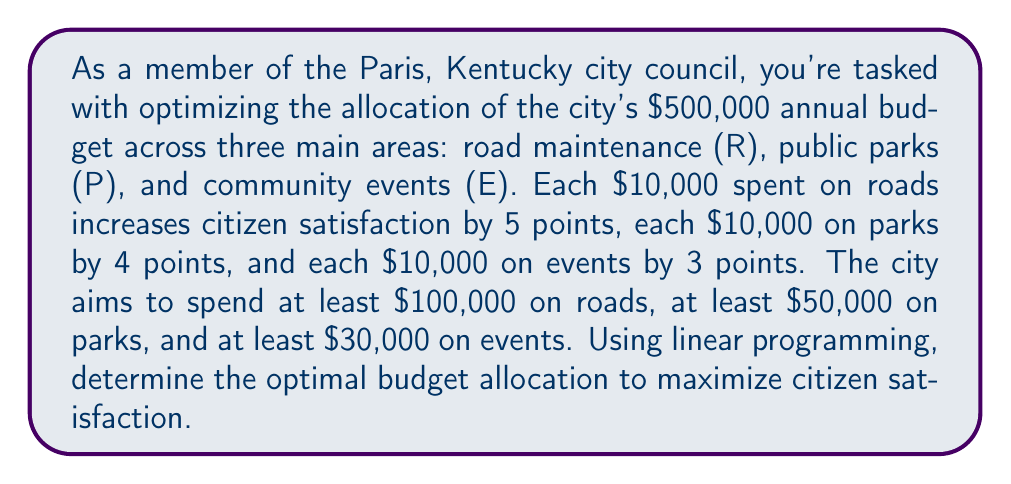Provide a solution to this math problem. Let's approach this step-by-step using linear programming:

1) Define variables:
   $R$ = amount spent on roads (in $10,000 units)
   $P$ = amount spent on parks (in $10,000 units)
   $E$ = amount spent on events (in $10,000 units)

2) Objective function:
   Maximize $Z = 5R + 4P + 3E$ (citizen satisfaction)

3) Constraints:
   $R + P + E \leq 50$ (total budget constraint)
   $R \geq 10$ (minimum road spending)
   $P \geq 5$ (minimum park spending)
   $E \geq 3$ (minimum event spending)
   $R, P, E \geq 0$ (non-negativity constraints)

4) Set up the linear programming tableau:
   $$
   \begin{array}{c|ccc|c}
     & R & P & E & RHS \\
   \hline
   Z & -5 & -4 & -3 & 0 \\
   S_1 & 1 & 1 & 1 & 50 \\
   S_2 & -1 & 0 & 0 & -10 \\
   S_3 & 0 & -1 & 0 & -5 \\
   S_4 & 0 & 0 & -1 & -3 \\
   \end{array}
   $$

5) Solve using the simplex method:
   After several iterations, we reach the optimal solution:
   $$
   \begin{array}{c|ccc|c}
     & R & P & E & RHS \\
   \hline
   Z & 0 & 0 & 0 & 230 \\
   R & 1 & 0 & 0 & 42 \\
   P & 0 & 1 & 0 & 5 \\
   E & 0 & 0 & 1 & 3 \\
   \end{array}
   $$

6) Interpret the solution:
   $R = 42$, $P = 5$, $E = 3$
   In actual dollar amounts:
   Roads: $420,000
   Parks: $50,000
   Events: $30,000

The maximum citizen satisfaction score is 230 points.
Answer: Roads: $420,000, Parks: $50,000, Events: $30,000 